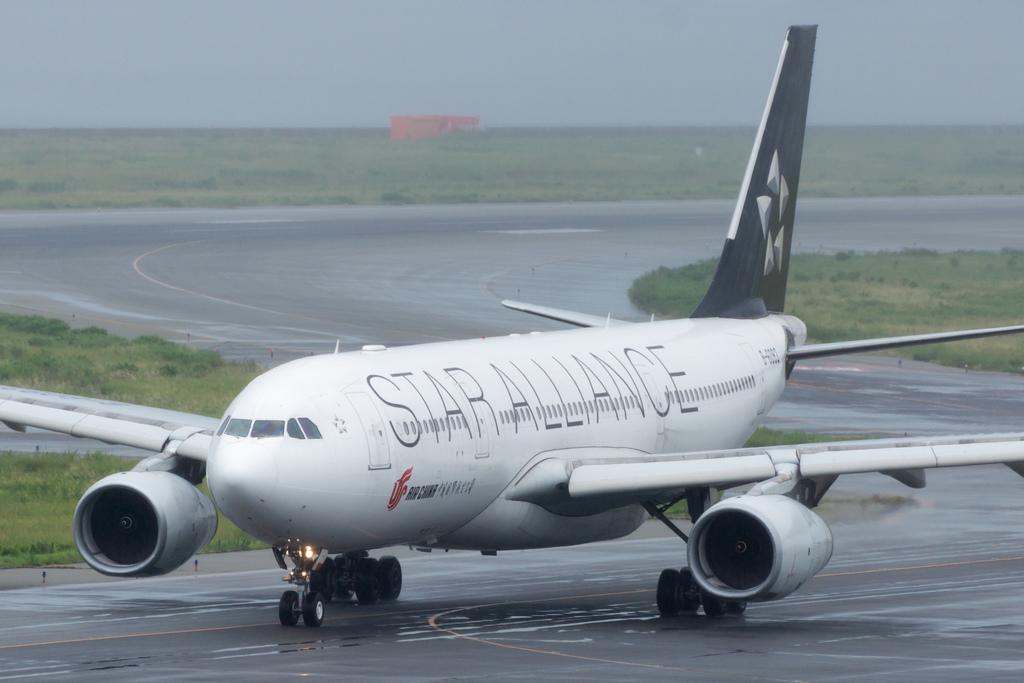<image>
Write a terse but informative summary of the picture. A Star Alliance airplane is parked but started on a runway. 